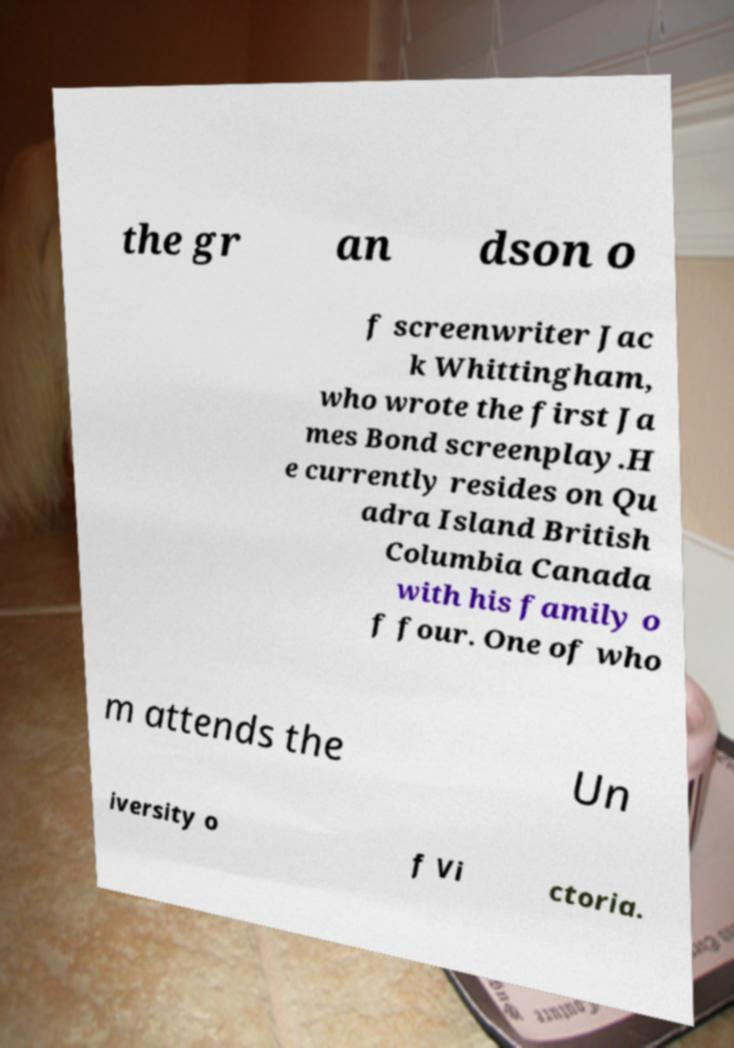For documentation purposes, I need the text within this image transcribed. Could you provide that? the gr an dson o f screenwriter Jac k Whittingham, who wrote the first Ja mes Bond screenplay.H e currently resides on Qu adra Island British Columbia Canada with his family o f four. One of who m attends the Un iversity o f Vi ctoria. 